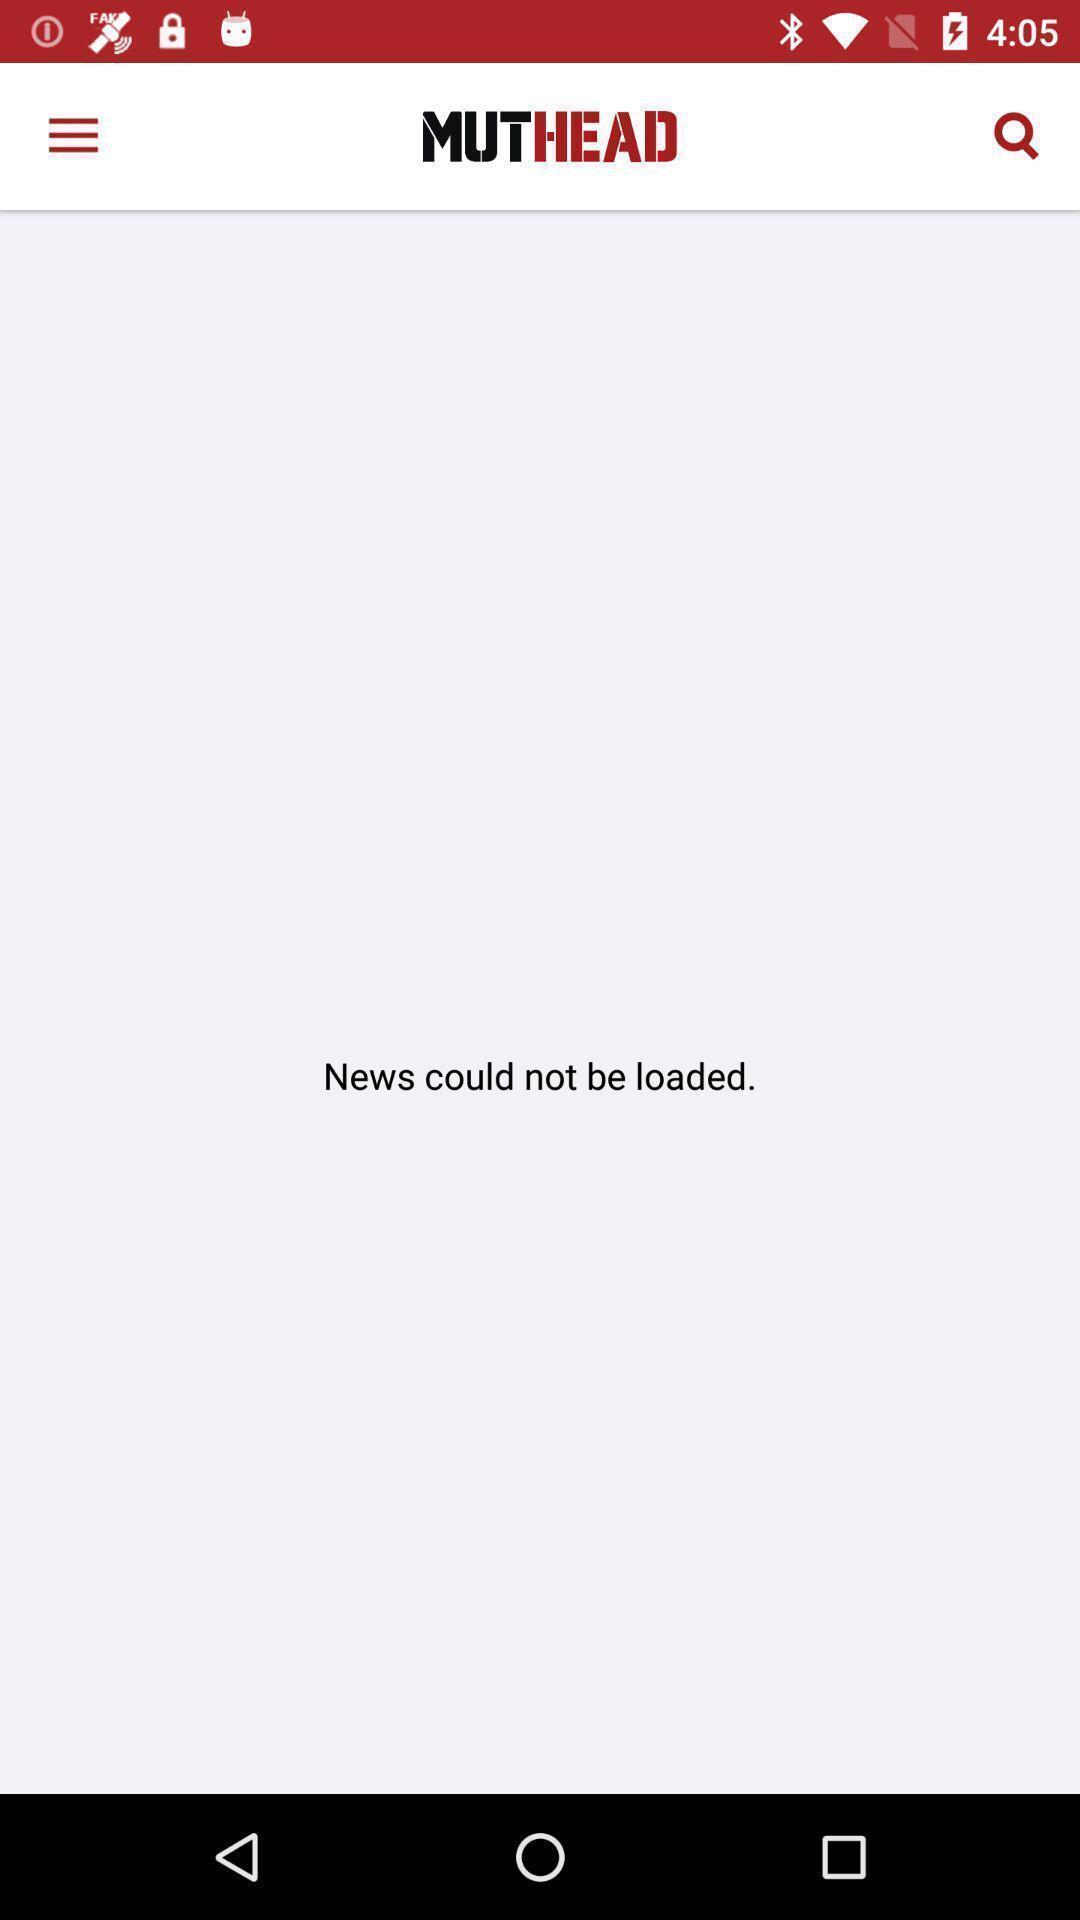Describe the content in this image. Page displaying news could not be loaded. 